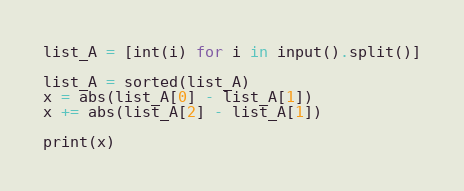Convert code to text. <code><loc_0><loc_0><loc_500><loc_500><_Python_>list_A = [int(i) for i in input().split()]

list_A = sorted(list_A)
x = abs(list_A[0] - list_A[1])
x += abs(list_A[2] - list_A[1])

print(x)
</code> 